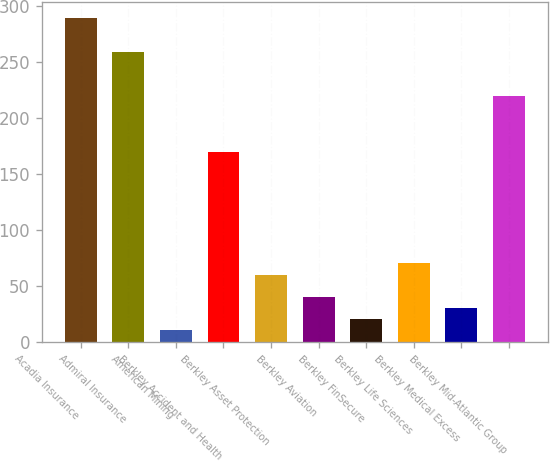Convert chart. <chart><loc_0><loc_0><loc_500><loc_500><bar_chart><fcel>Acadia Insurance<fcel>Admiral Insurance<fcel>American Mining<fcel>Berkley Accident and Health<fcel>Berkley Asset Protection<fcel>Berkley Aviation<fcel>Berkley FinSecure<fcel>Berkley Life Sciences<fcel>Berkley Medical Excess<fcel>Berkley Mid-Atlantic Group<nl><fcel>289.24<fcel>259.36<fcel>10.36<fcel>169.72<fcel>60.16<fcel>40.24<fcel>20.32<fcel>70.12<fcel>30.28<fcel>219.52<nl></chart> 